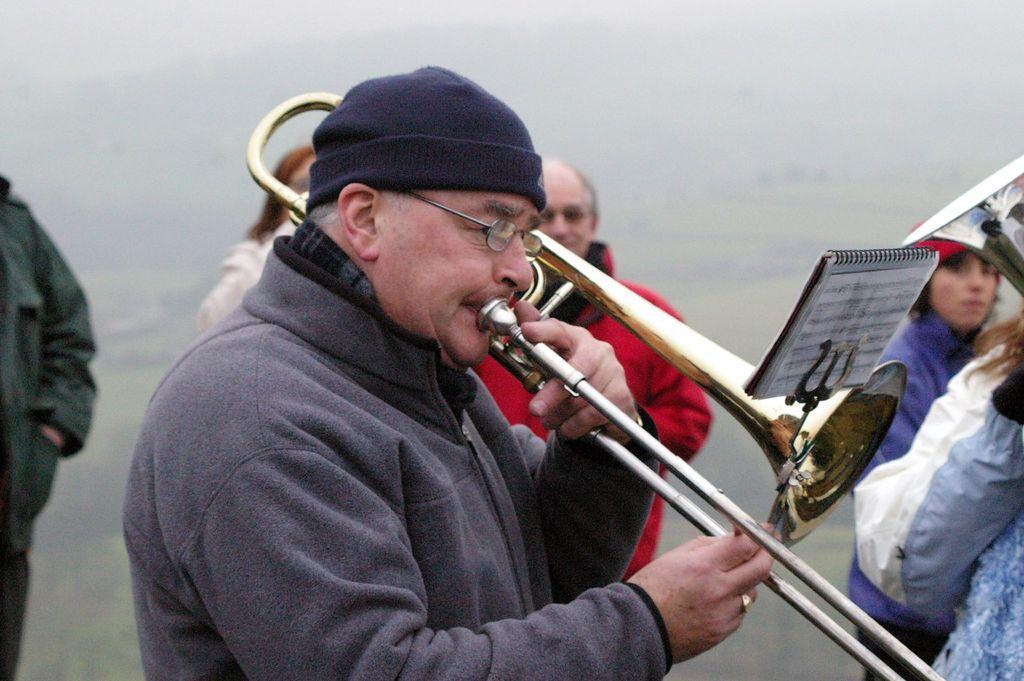What are the people in the image doing? The people in the image are playing musical instruments. What can be seen in the background of the image? There are trees and the sky visible in the background of the image. Can you describe the setting of the image? The image is likely taken during the day, as there is no indication of darkness or artificial lighting. What type of wish can be granted by the trees in the image? There are no wishes or magical elements associated with the trees in the image; they are simply part of the background. 